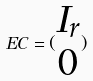Convert formula to latex. <formula><loc_0><loc_0><loc_500><loc_500>E C = ( \begin{matrix} I _ { r } \\ 0 \end{matrix} )</formula> 